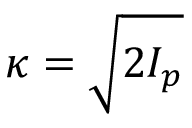Convert formula to latex. <formula><loc_0><loc_0><loc_500><loc_500>\kappa = \sqrt { 2 I _ { p } }</formula> 